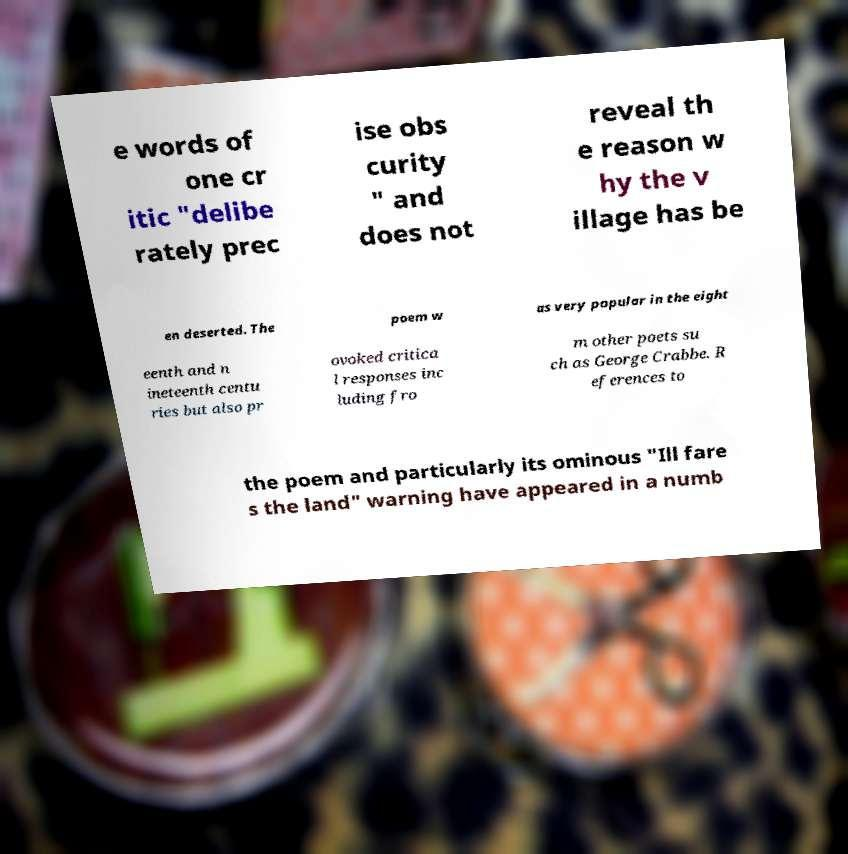Could you assist in decoding the text presented in this image and type it out clearly? e words of one cr itic "delibe rately prec ise obs curity " and does not reveal th e reason w hy the v illage has be en deserted. The poem w as very popular in the eight eenth and n ineteenth centu ries but also pr ovoked critica l responses inc luding fro m other poets su ch as George Crabbe. R eferences to the poem and particularly its ominous "Ill fare s the land" warning have appeared in a numb 